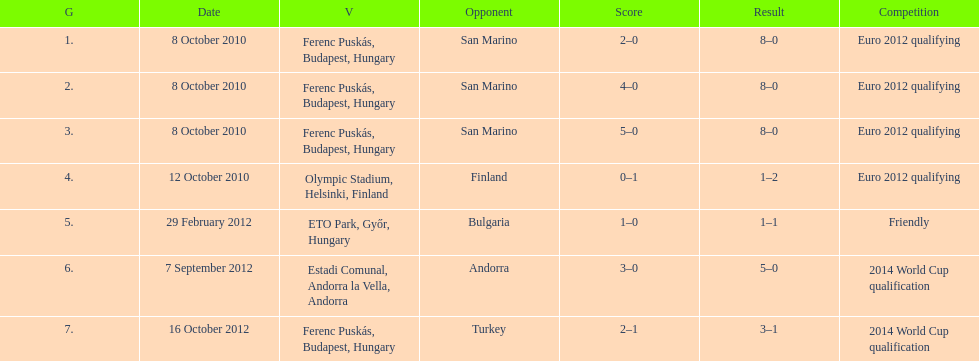How many games did he score but his team lost? 1. 